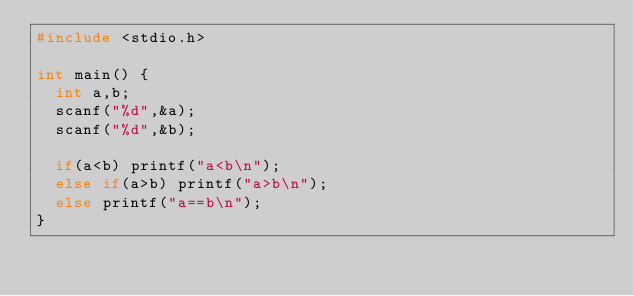Convert code to text. <code><loc_0><loc_0><loc_500><loc_500><_C_>#include <stdio.h>
 
int main() {
  int a,b;
  scanf("%d",&a);
  scanf("%d",&b);

  if(a<b) printf("a<b\n");
  else if(a>b) printf("a>b\n");
  else printf("a==b\n");
}
</code> 